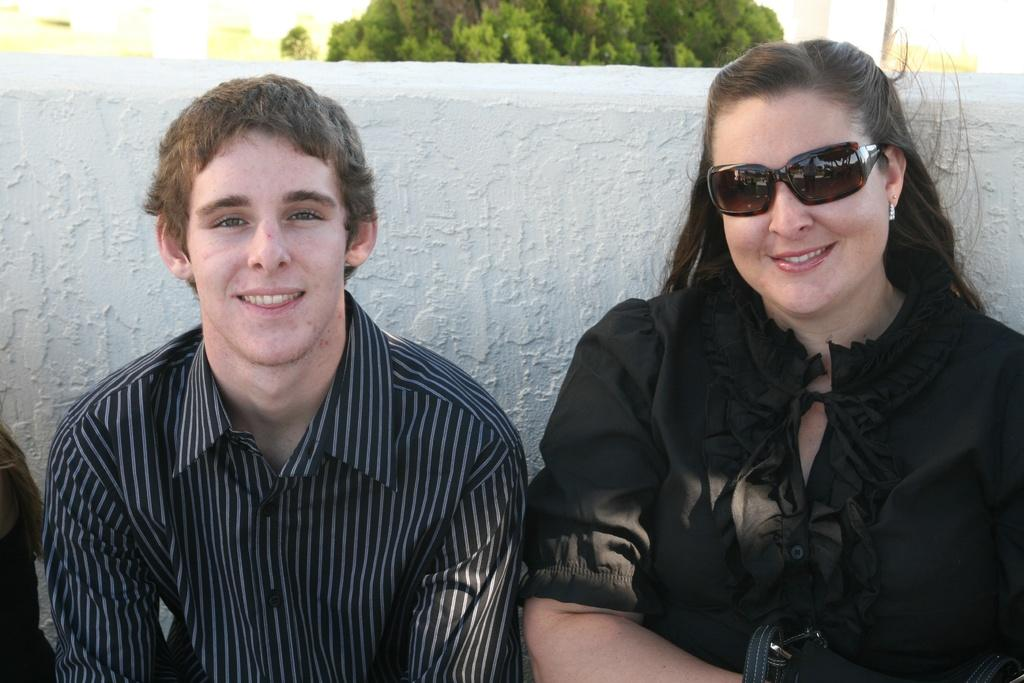How many people are in the image? There are two persons in the image. What expressions do the persons have? Both persons are smiling. Can you describe the background of the image? The persons may be in front of a wall. What natural element can be seen in the image? There is a tree visible at the top of the image. What type of payment is being exchanged between the two persons in the image? There is no indication of any payment being exchanged in the image. Can you see a chessboard or any chess pieces in the image? There is no chessboard or chess pieces visible in the image. 